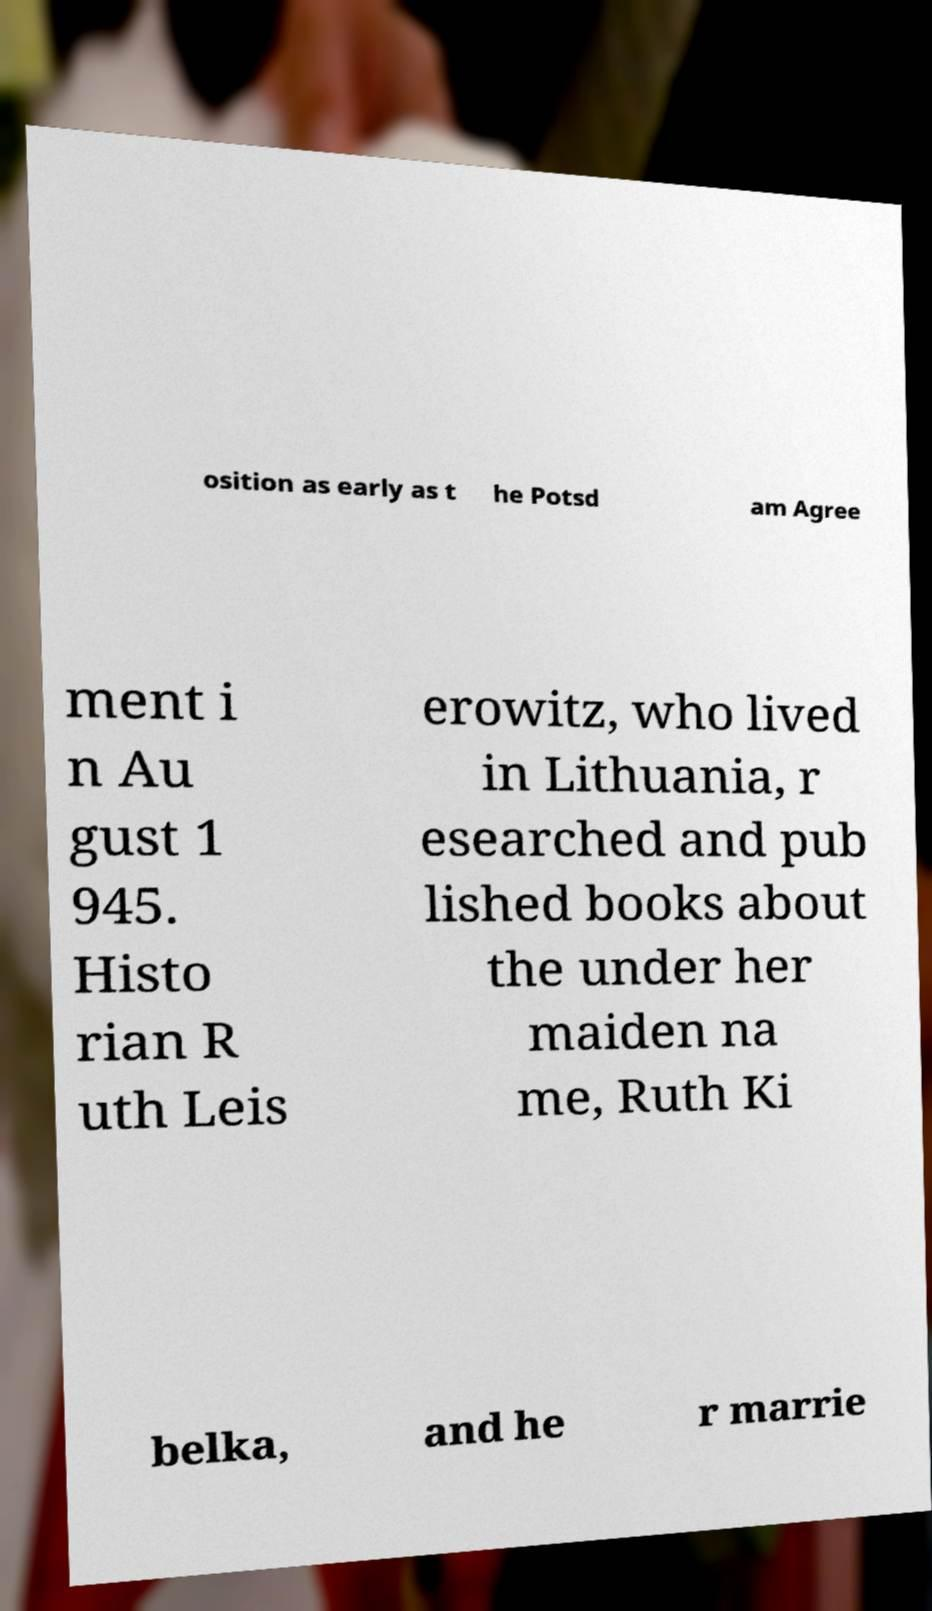Please identify and transcribe the text found in this image. osition as early as t he Potsd am Agree ment i n Au gust 1 945. Histo rian R uth Leis erowitz, who lived in Lithuania, r esearched and pub lished books about the under her maiden na me, Ruth Ki belka, and he r marrie 